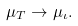Convert formula to latex. <formula><loc_0><loc_0><loc_500><loc_500>\mu _ { T } \to \mu _ { \iota } .</formula> 